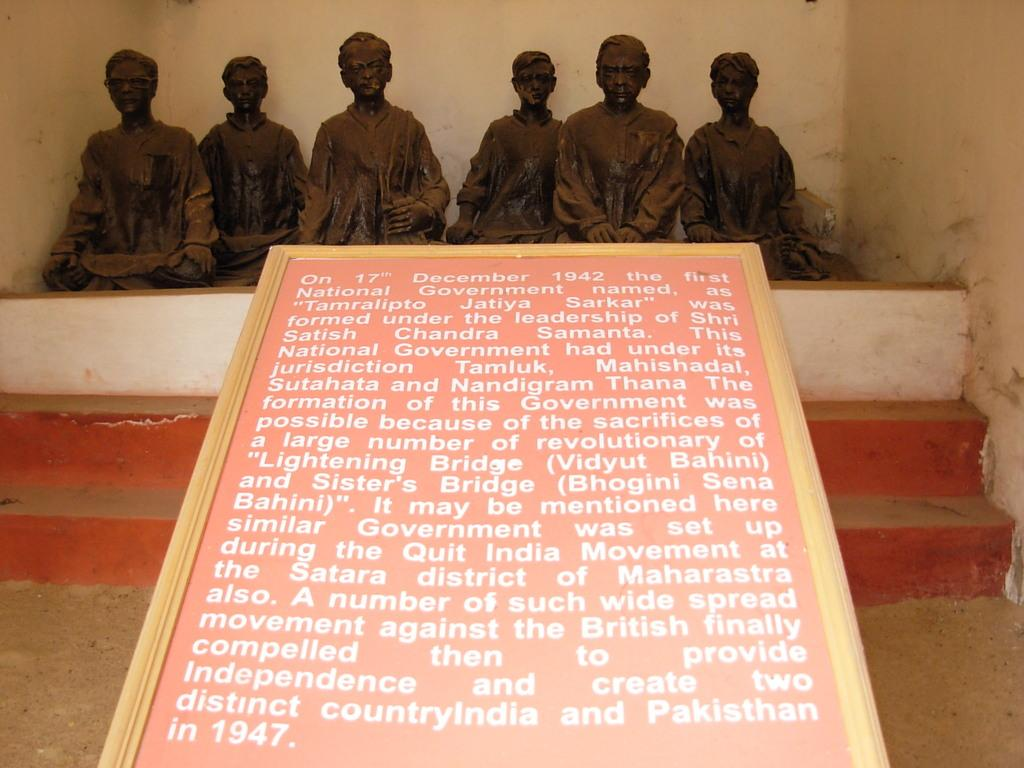What is located at the front of the image? There is a board with text in the front of the image. What can be seen in the background of the image? There are statues in the background of the image. What architectural feature is present in the center of the image? There are steps in the center of the image. How many matches are visible in the image? There are no matches present in the image. What type of grain is growing in the background of the image? There is no grain visible in the image; it features a board with text, statues, and steps. 